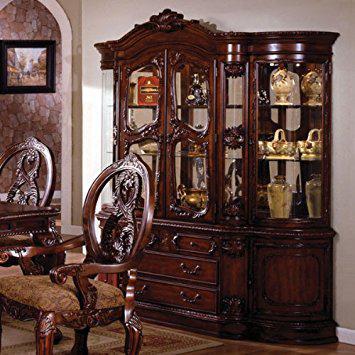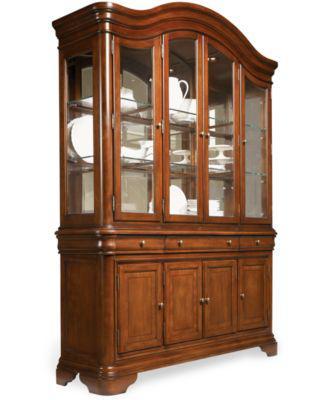The first image is the image on the left, the second image is the image on the right. Assess this claim about the two images: "All cabinets shown are rich brown wood tones.". Correct or not? Answer yes or no. Yes. 